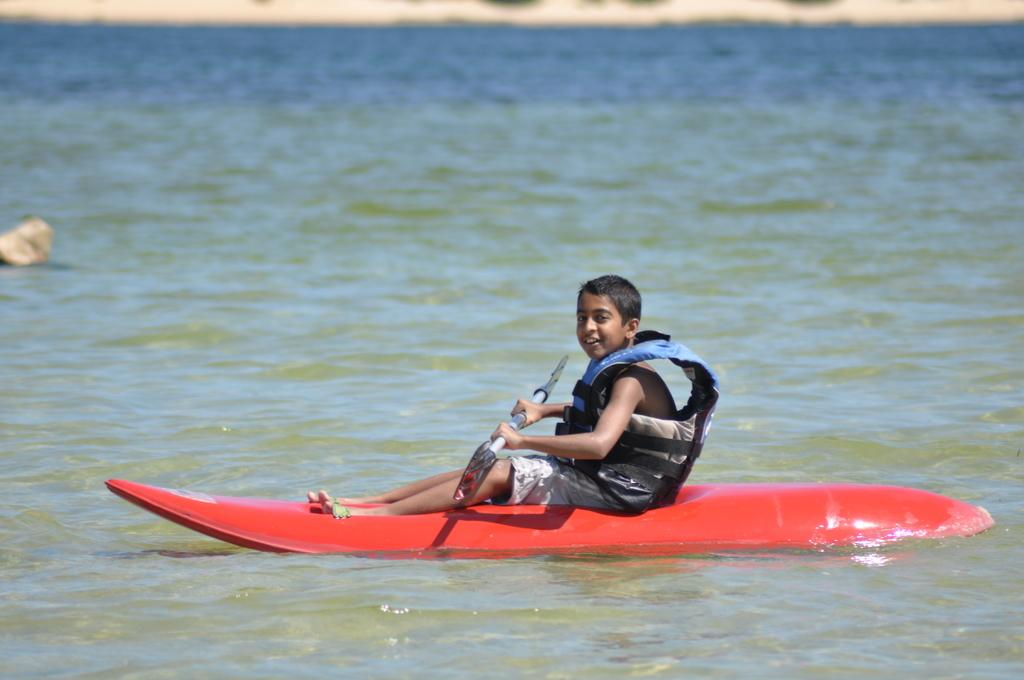What is the main feature of the image? There is water in the image. What type of vehicle is on the water? There is a red color air boat on the water. Who is in the air boat? A boy is sitting in the air boat. What is the boy holding in his hand? The boy is holding paddles in his hand. What safety precaution is the boy wearing? The boy is wearing a life jacket. Can you hear the boy laughing in the hospital with his family in the image? There is no reference to a hospital or family in the image, and no sound can be heard from a still image. 